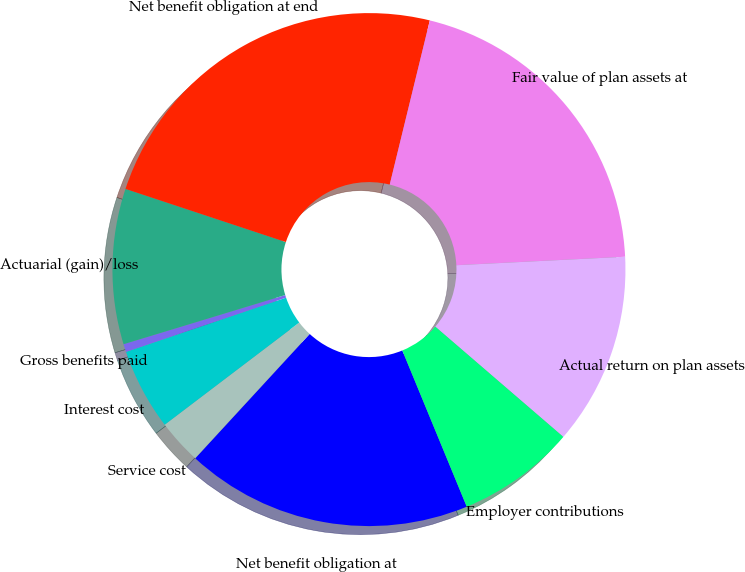Convert chart to OTSL. <chart><loc_0><loc_0><loc_500><loc_500><pie_chart><fcel>Net benefit obligation at<fcel>Service cost<fcel>Interest cost<fcel>Gross benefits paid<fcel>Actuarial (gain)/loss<fcel>Net benefit obligation at end<fcel>Fair value of plan assets at<fcel>Actual return on plan assets<fcel>Employer contributions<nl><fcel>18.07%<fcel>2.82%<fcel>5.14%<fcel>0.5%<fcel>9.79%<fcel>23.72%<fcel>20.39%<fcel>12.11%<fcel>7.46%<nl></chart> 